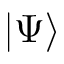Convert formula to latex. <formula><loc_0><loc_0><loc_500><loc_500>| \Psi \rangle</formula> 